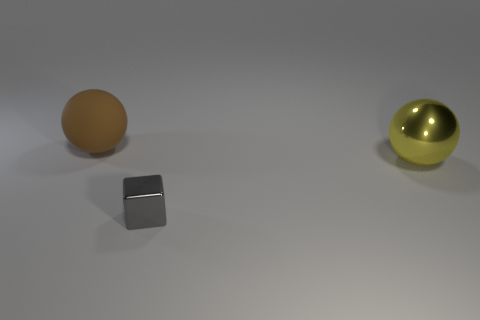Are there any other things that have the same shape as the tiny object?
Keep it short and to the point. No. Are there any other things that are the same size as the gray object?
Provide a short and direct response. No. How many cubes are big yellow metallic objects or shiny objects?
Your answer should be compact. 1. Is the shape of the large yellow metallic object the same as the metal thing that is in front of the large yellow metallic thing?
Make the answer very short. No. How many spheres have the same size as the yellow shiny object?
Keep it short and to the point. 1. There is a big brown thing behind the shiny cube; is its shape the same as the big object on the right side of the big brown sphere?
Offer a terse response. Yes. What color is the big rubber ball behind the big object to the right of the matte ball?
Make the answer very short. Brown. What color is the other thing that is the same shape as the big metal object?
Provide a short and direct response. Brown. Are there any other things that are the same material as the brown sphere?
Provide a short and direct response. No. There is a yellow shiny thing that is the same shape as the big rubber object; what size is it?
Make the answer very short. Large. 